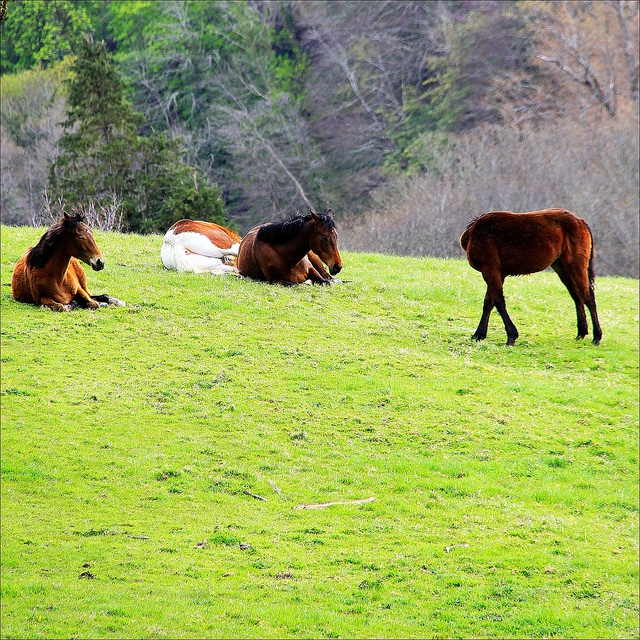Describe the objects in this image and their specific colors. I can see horse in black, maroon, darkgray, and khaki tones, horse in black, maroon, brown, and orange tones, horse in black, maroon, gray, and brown tones, and horse in black, white, and tan tones in this image. 